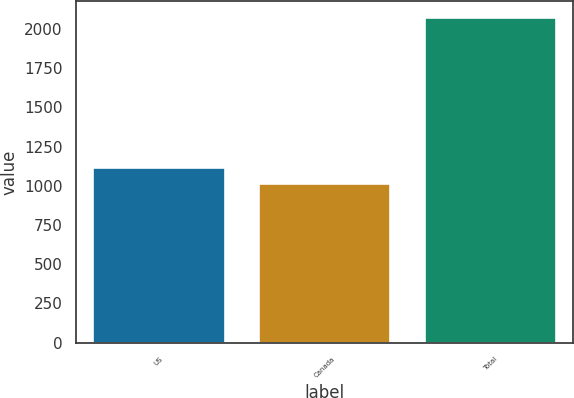Convert chart to OTSL. <chart><loc_0><loc_0><loc_500><loc_500><bar_chart><fcel>US<fcel>Canada<fcel>Total<nl><fcel>1120.9<fcel>1015<fcel>2074<nl></chart> 